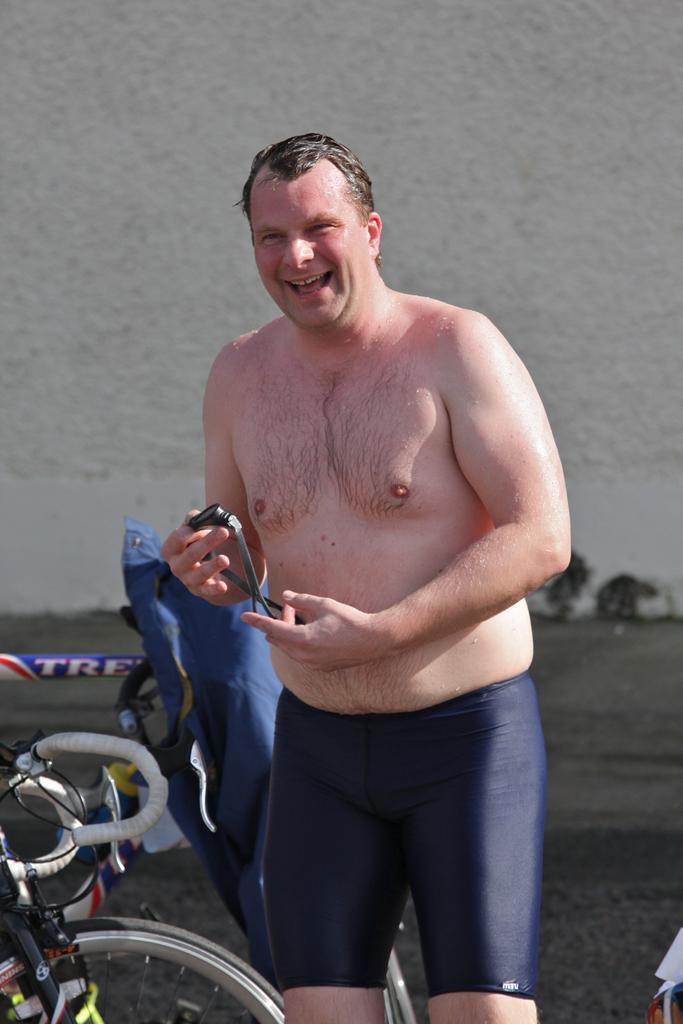Could you give a brief overview of what you see in this image? In the picture I can see a man is standing and holding something in the hand. In the background I can see some other things. 